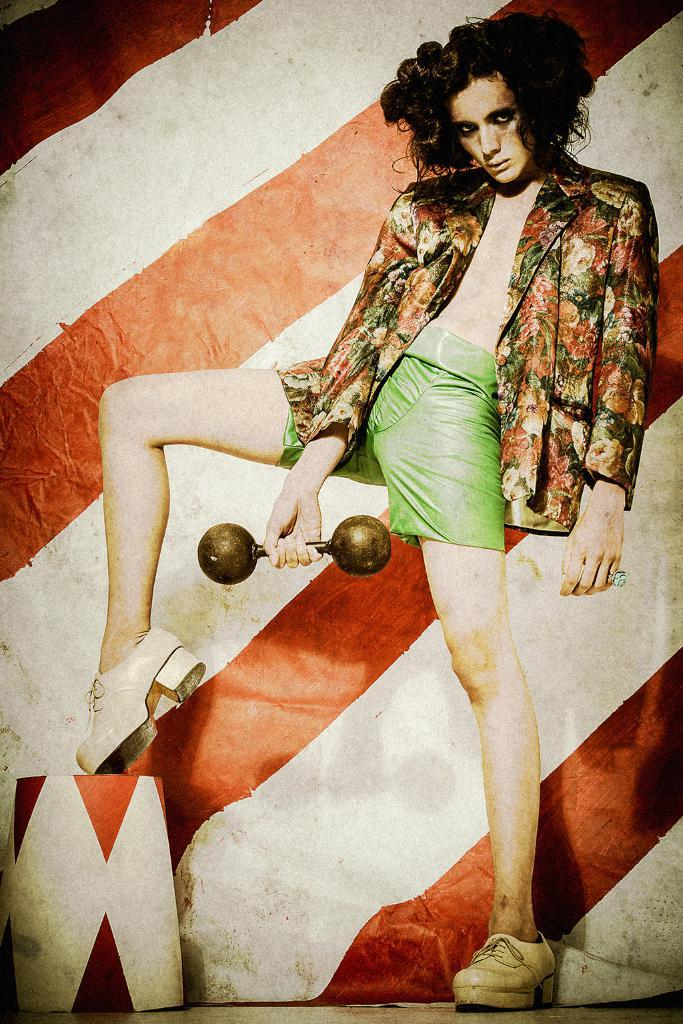What is the main subject of the image? There is a woman in the image. What is the woman doing in the image? The woman is standing and holding a dumbbell. What can be seen in the background of the image? There is a wall in the background of the image. What is located on the left side of the image? There is an object on the left side of the image. What type of tin can be seen on the woman's head in the image? There is no tin present on the woman's head in the image. What place does the woman represent in the image? The image does not depict a specific place; it is focused on the woman and her actions. 